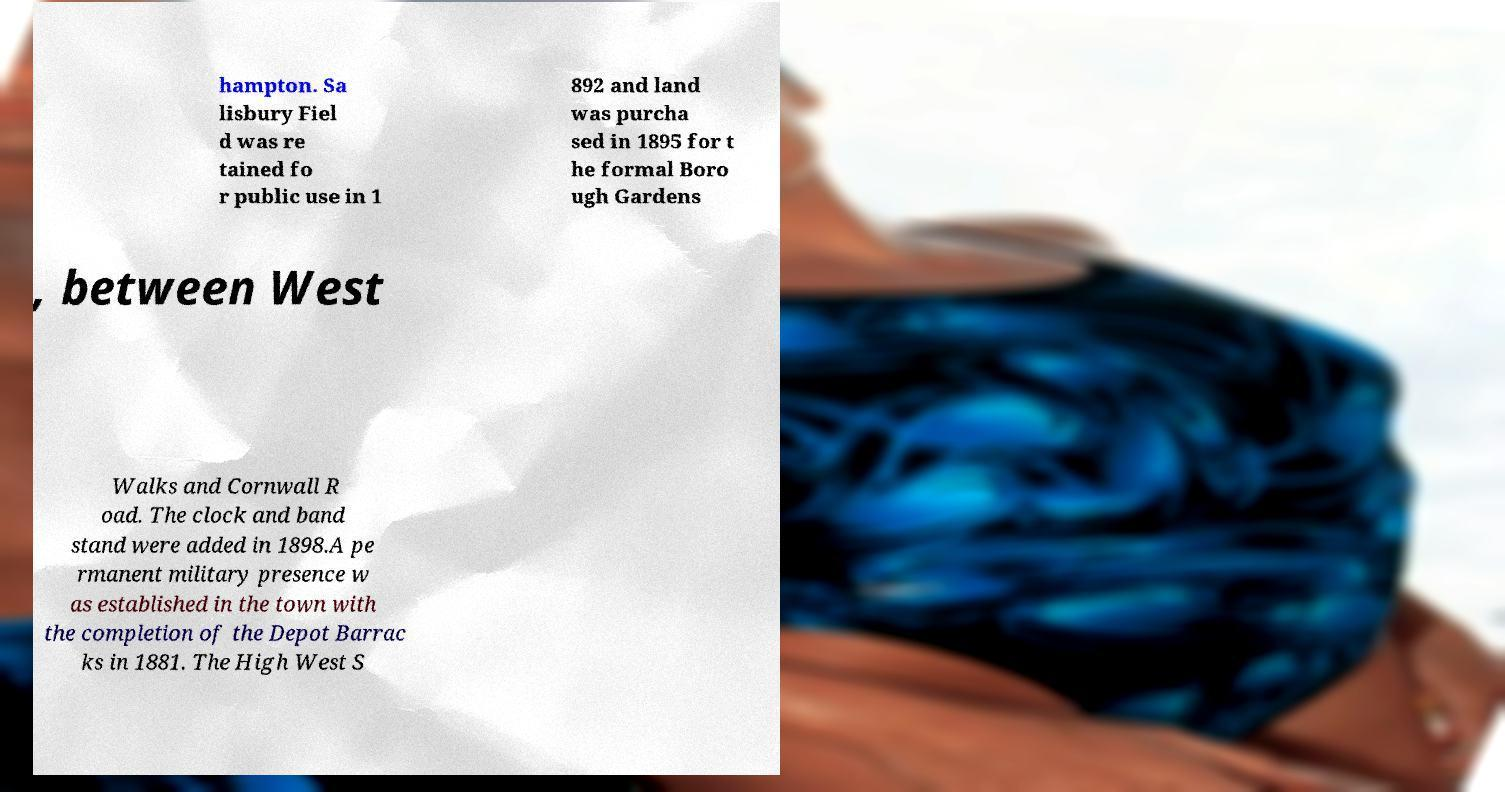Please read and relay the text visible in this image. What does it say? hampton. Sa lisbury Fiel d was re tained fo r public use in 1 892 and land was purcha sed in 1895 for t he formal Boro ugh Gardens , between West Walks and Cornwall R oad. The clock and band stand were added in 1898.A pe rmanent military presence w as established in the town with the completion of the Depot Barrac ks in 1881. The High West S 